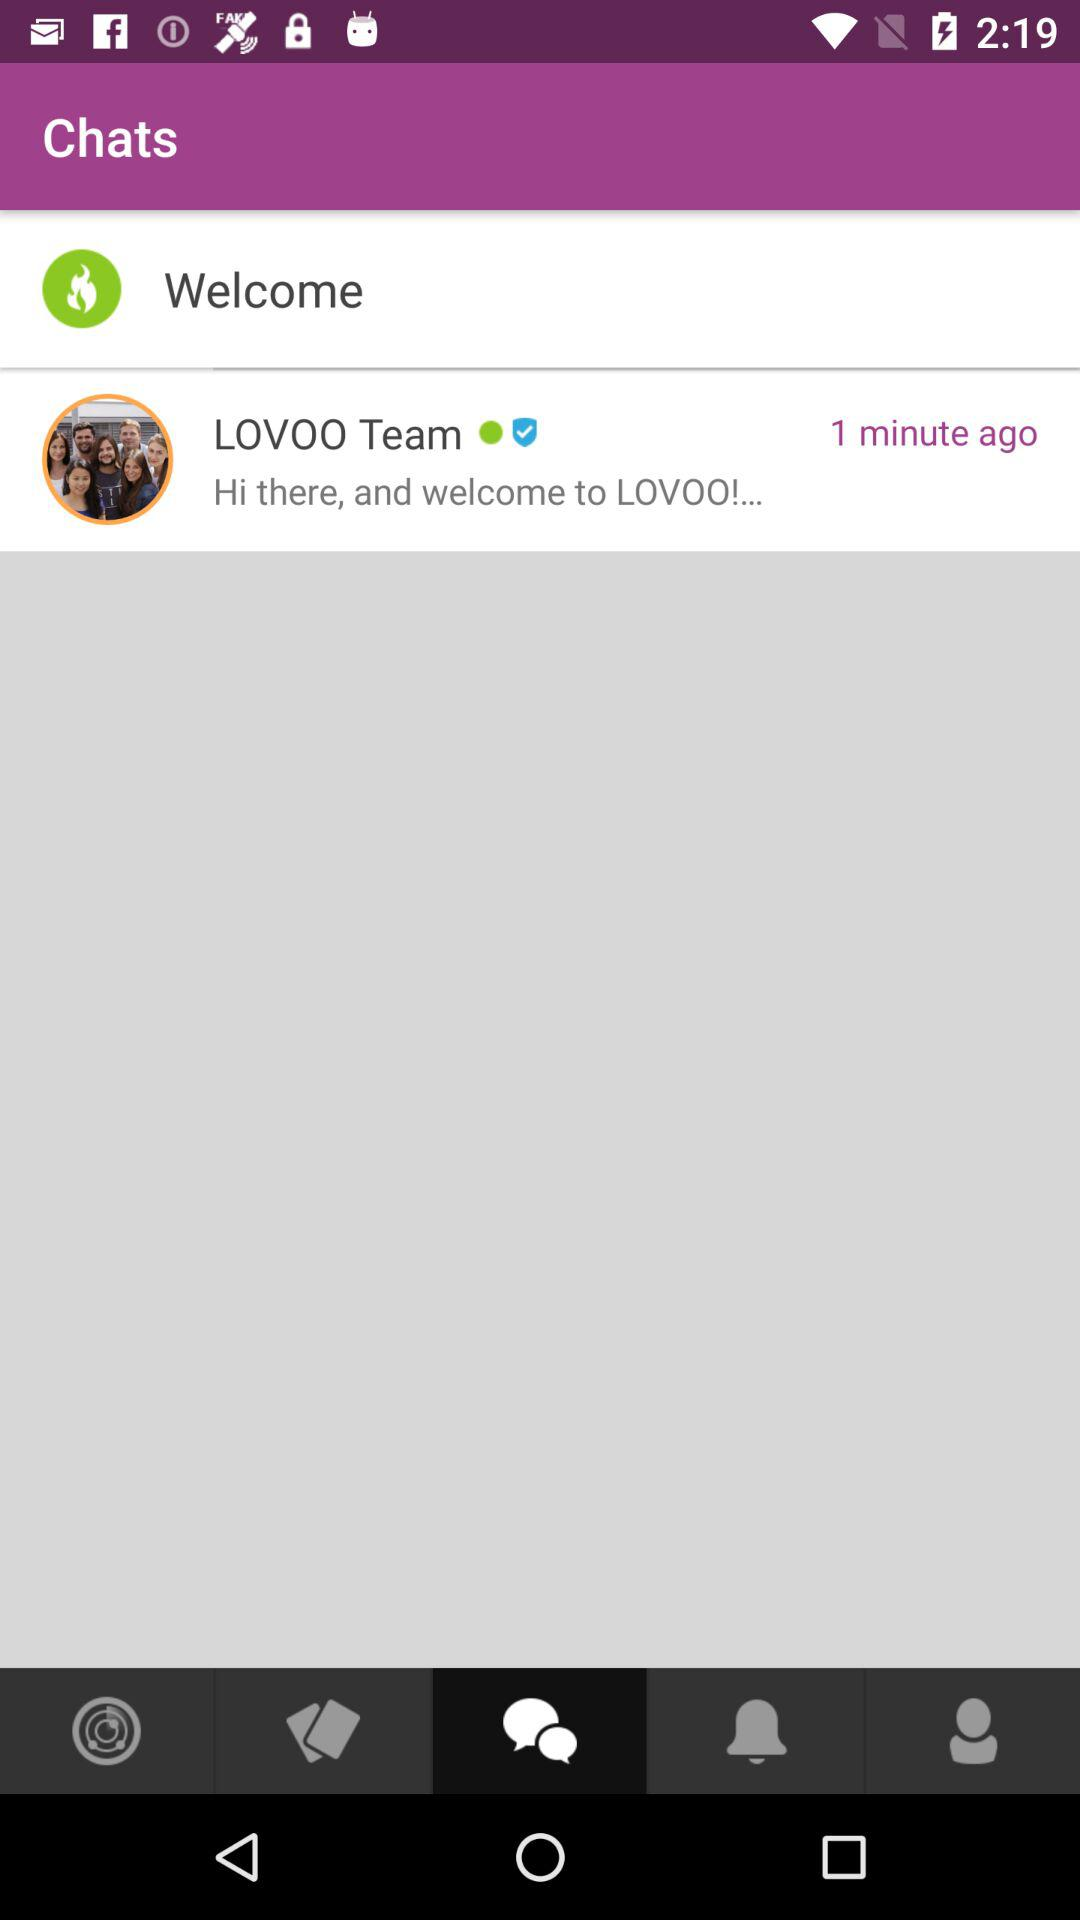When is the alarm set?
When the provided information is insufficient, respond with <no answer>. <no answer> 